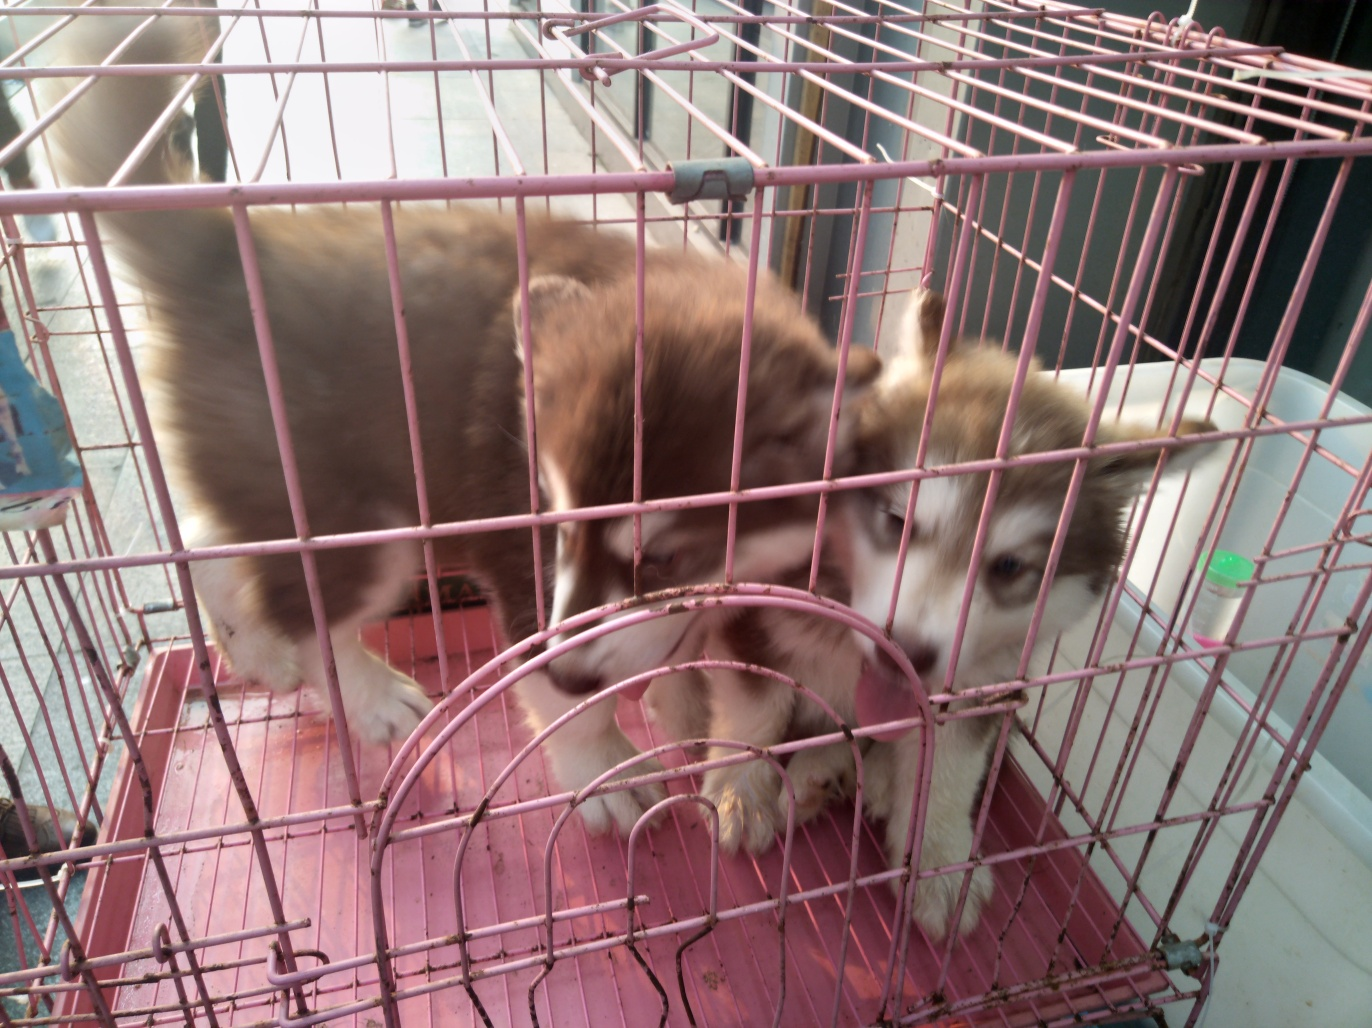Can you tell if these dogs are healthy? It's challenging to accurately determine the health of the dogs from this single image without a physical examination by a veterinarian. However, both dogs appear to have a good coat condition and are alert, which are generally positive indicators. For a comprehensive health evaluation, a vet check-up is recommended. 